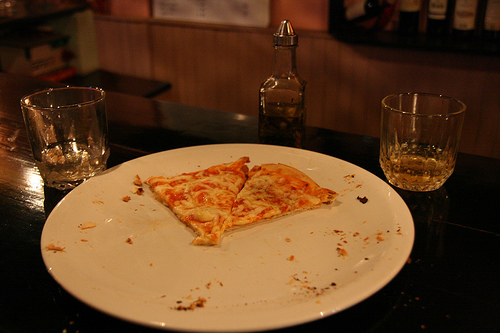What kind of setting does this image suggest about the meal? The setting appears casual, likely a quick dining scenario possibly in a bar or a cafe, emphasized by the presence of two glasses that might have held alcoholic beverages, suggesting a relaxed mealtime atmosphere. 